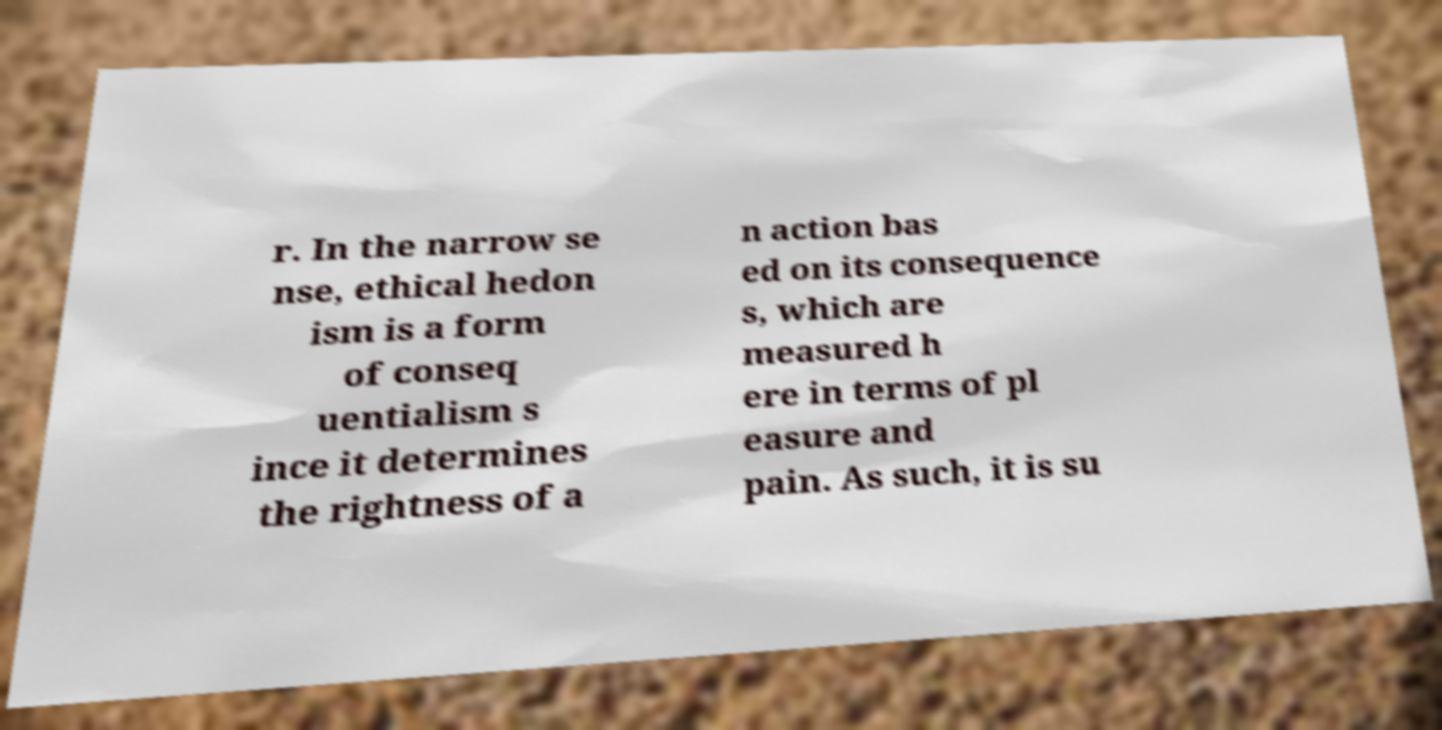Please identify and transcribe the text found in this image. r. In the narrow se nse, ethical hedon ism is a form of conseq uentialism s ince it determines the rightness of a n action bas ed on its consequence s, which are measured h ere in terms of pl easure and pain. As such, it is su 